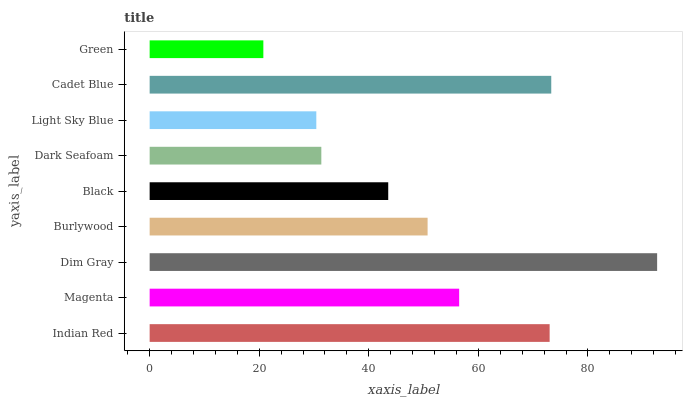Is Green the minimum?
Answer yes or no. Yes. Is Dim Gray the maximum?
Answer yes or no. Yes. Is Magenta the minimum?
Answer yes or no. No. Is Magenta the maximum?
Answer yes or no. No. Is Indian Red greater than Magenta?
Answer yes or no. Yes. Is Magenta less than Indian Red?
Answer yes or no. Yes. Is Magenta greater than Indian Red?
Answer yes or no. No. Is Indian Red less than Magenta?
Answer yes or no. No. Is Burlywood the high median?
Answer yes or no. Yes. Is Burlywood the low median?
Answer yes or no. Yes. Is Light Sky Blue the high median?
Answer yes or no. No. Is Indian Red the low median?
Answer yes or no. No. 